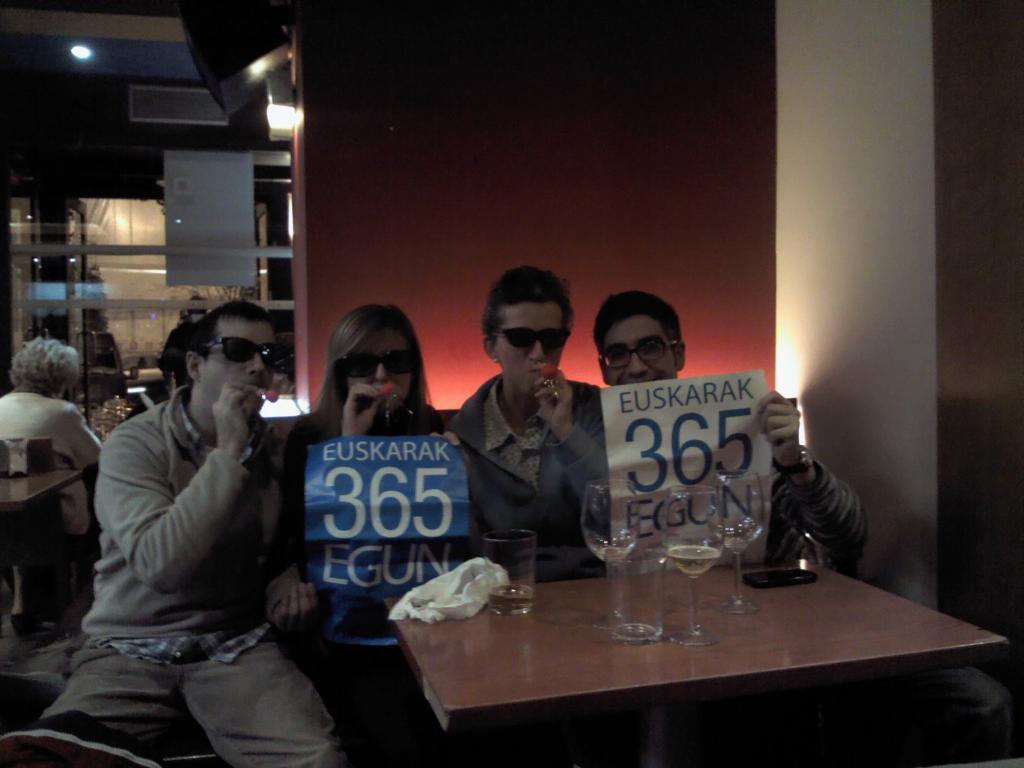How would you summarize this image in a sentence or two? In this picture there are four person sitting on a couch. This woman and man holding a poster. In-front of them there is a table. On that table there are three glasses, a black mobile and a white cloth. On the left side there is an old woman who is sitting on a chair. On the top left there is a light. On the right side there is a wall which is in white color. This three person holding some red object in their mouth. 